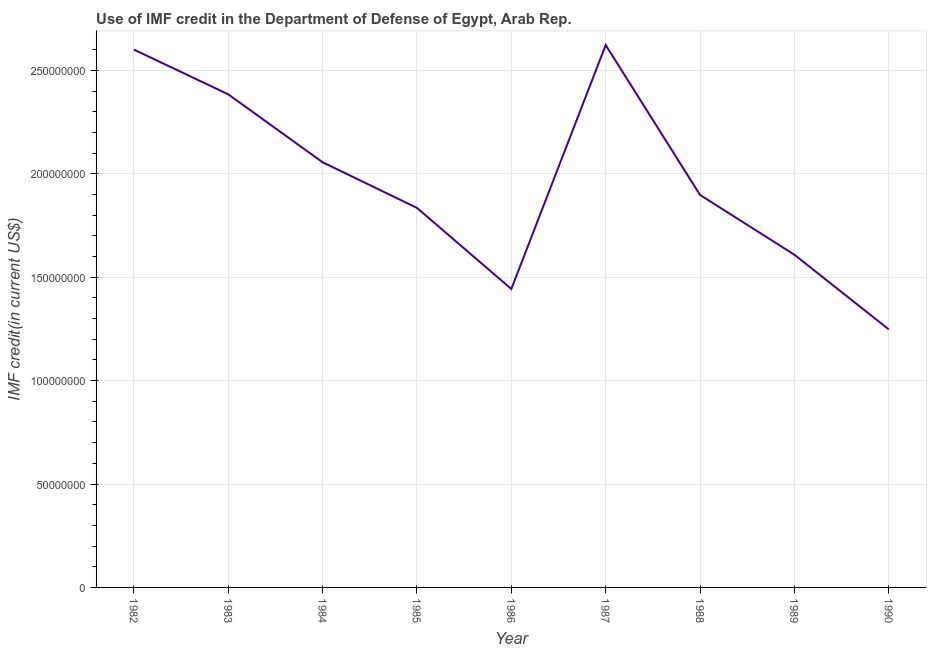What is the use of imf credit in dod in 1987?
Your answer should be very brief. 2.62e+08. Across all years, what is the maximum use of imf credit in dod?
Offer a terse response. 2.62e+08. Across all years, what is the minimum use of imf credit in dod?
Make the answer very short. 1.25e+08. In which year was the use of imf credit in dod minimum?
Your answer should be very brief. 1990. What is the sum of the use of imf credit in dod?
Offer a very short reply. 1.77e+09. What is the difference between the use of imf credit in dod in 1988 and 1990?
Make the answer very short. 6.50e+07. What is the average use of imf credit in dod per year?
Provide a succinct answer. 1.97e+08. What is the median use of imf credit in dod?
Provide a short and direct response. 1.90e+08. What is the ratio of the use of imf credit in dod in 1982 to that in 1983?
Provide a short and direct response. 1.09. Is the difference between the use of imf credit in dod in 1985 and 1986 greater than the difference between any two years?
Your answer should be very brief. No. What is the difference between the highest and the second highest use of imf credit in dod?
Offer a very short reply. 2.21e+06. Is the sum of the use of imf credit in dod in 1985 and 1988 greater than the maximum use of imf credit in dod across all years?
Ensure brevity in your answer.  Yes. What is the difference between the highest and the lowest use of imf credit in dod?
Provide a short and direct response. 1.37e+08. In how many years, is the use of imf credit in dod greater than the average use of imf credit in dod taken over all years?
Offer a very short reply. 4. Does the graph contain grids?
Offer a very short reply. Yes. What is the title of the graph?
Ensure brevity in your answer.  Use of IMF credit in the Department of Defense of Egypt, Arab Rep. What is the label or title of the X-axis?
Give a very brief answer. Year. What is the label or title of the Y-axis?
Provide a short and direct response. IMF credit(in current US$). What is the IMF credit(in current US$) in 1982?
Give a very brief answer. 2.60e+08. What is the IMF credit(in current US$) of 1983?
Give a very brief answer. 2.38e+08. What is the IMF credit(in current US$) of 1984?
Your answer should be very brief. 2.06e+08. What is the IMF credit(in current US$) of 1985?
Your answer should be very brief. 1.84e+08. What is the IMF credit(in current US$) of 1986?
Provide a short and direct response. 1.44e+08. What is the IMF credit(in current US$) of 1987?
Give a very brief answer. 2.62e+08. What is the IMF credit(in current US$) in 1988?
Make the answer very short. 1.90e+08. What is the IMF credit(in current US$) in 1989?
Your answer should be compact. 1.61e+08. What is the IMF credit(in current US$) in 1990?
Offer a very short reply. 1.25e+08. What is the difference between the IMF credit(in current US$) in 1982 and 1983?
Keep it short and to the point. 2.16e+07. What is the difference between the IMF credit(in current US$) in 1982 and 1984?
Your response must be concise. 5.45e+07. What is the difference between the IMF credit(in current US$) in 1982 and 1985?
Your answer should be compact. 7.65e+07. What is the difference between the IMF credit(in current US$) in 1982 and 1986?
Provide a short and direct response. 1.16e+08. What is the difference between the IMF credit(in current US$) in 1982 and 1987?
Your answer should be very brief. -2.21e+06. What is the difference between the IMF credit(in current US$) in 1982 and 1988?
Your answer should be compact. 7.03e+07. What is the difference between the IMF credit(in current US$) in 1982 and 1989?
Your response must be concise. 9.92e+07. What is the difference between the IMF credit(in current US$) in 1982 and 1990?
Ensure brevity in your answer.  1.35e+08. What is the difference between the IMF credit(in current US$) in 1983 and 1984?
Your response must be concise. 3.28e+07. What is the difference between the IMF credit(in current US$) in 1983 and 1985?
Your answer should be very brief. 5.49e+07. What is the difference between the IMF credit(in current US$) in 1983 and 1986?
Your answer should be compact. 9.41e+07. What is the difference between the IMF credit(in current US$) in 1983 and 1987?
Give a very brief answer. -2.38e+07. What is the difference between the IMF credit(in current US$) in 1983 and 1988?
Keep it short and to the point. 4.86e+07. What is the difference between the IMF credit(in current US$) in 1983 and 1989?
Your answer should be very brief. 7.76e+07. What is the difference between the IMF credit(in current US$) in 1983 and 1990?
Your answer should be compact. 1.14e+08. What is the difference between the IMF credit(in current US$) in 1984 and 1985?
Give a very brief answer. 2.21e+07. What is the difference between the IMF credit(in current US$) in 1984 and 1986?
Your response must be concise. 6.13e+07. What is the difference between the IMF credit(in current US$) in 1984 and 1987?
Ensure brevity in your answer.  -5.67e+07. What is the difference between the IMF credit(in current US$) in 1984 and 1988?
Provide a succinct answer. 1.58e+07. What is the difference between the IMF credit(in current US$) in 1984 and 1989?
Offer a terse response. 4.47e+07. What is the difference between the IMF credit(in current US$) in 1984 and 1990?
Your response must be concise. 8.08e+07. What is the difference between the IMF credit(in current US$) in 1985 and 1986?
Offer a very short reply. 3.92e+07. What is the difference between the IMF credit(in current US$) in 1985 and 1987?
Make the answer very short. -7.87e+07. What is the difference between the IMF credit(in current US$) in 1985 and 1988?
Your response must be concise. -6.26e+06. What is the difference between the IMF credit(in current US$) in 1985 and 1989?
Provide a short and direct response. 2.26e+07. What is the difference between the IMF credit(in current US$) in 1985 and 1990?
Your answer should be compact. 5.87e+07. What is the difference between the IMF credit(in current US$) in 1986 and 1987?
Keep it short and to the point. -1.18e+08. What is the difference between the IMF credit(in current US$) in 1986 and 1988?
Your answer should be very brief. -4.55e+07. What is the difference between the IMF credit(in current US$) in 1986 and 1989?
Your answer should be very brief. -1.66e+07. What is the difference between the IMF credit(in current US$) in 1986 and 1990?
Keep it short and to the point. 1.95e+07. What is the difference between the IMF credit(in current US$) in 1987 and 1988?
Keep it short and to the point. 7.25e+07. What is the difference between the IMF credit(in current US$) in 1987 and 1989?
Give a very brief answer. 1.01e+08. What is the difference between the IMF credit(in current US$) in 1987 and 1990?
Provide a succinct answer. 1.37e+08. What is the difference between the IMF credit(in current US$) in 1988 and 1989?
Your answer should be compact. 2.89e+07. What is the difference between the IMF credit(in current US$) in 1988 and 1990?
Keep it short and to the point. 6.50e+07. What is the difference between the IMF credit(in current US$) in 1989 and 1990?
Give a very brief answer. 3.61e+07. What is the ratio of the IMF credit(in current US$) in 1982 to that in 1983?
Offer a very short reply. 1.09. What is the ratio of the IMF credit(in current US$) in 1982 to that in 1984?
Your response must be concise. 1.26. What is the ratio of the IMF credit(in current US$) in 1982 to that in 1985?
Your answer should be compact. 1.42. What is the ratio of the IMF credit(in current US$) in 1982 to that in 1986?
Ensure brevity in your answer.  1.8. What is the ratio of the IMF credit(in current US$) in 1982 to that in 1988?
Your answer should be very brief. 1.37. What is the ratio of the IMF credit(in current US$) in 1982 to that in 1989?
Give a very brief answer. 1.62. What is the ratio of the IMF credit(in current US$) in 1982 to that in 1990?
Offer a terse response. 2.08. What is the ratio of the IMF credit(in current US$) in 1983 to that in 1984?
Your response must be concise. 1.16. What is the ratio of the IMF credit(in current US$) in 1983 to that in 1985?
Make the answer very short. 1.3. What is the ratio of the IMF credit(in current US$) in 1983 to that in 1986?
Provide a short and direct response. 1.65. What is the ratio of the IMF credit(in current US$) in 1983 to that in 1987?
Provide a short and direct response. 0.91. What is the ratio of the IMF credit(in current US$) in 1983 to that in 1988?
Give a very brief answer. 1.26. What is the ratio of the IMF credit(in current US$) in 1983 to that in 1989?
Ensure brevity in your answer.  1.48. What is the ratio of the IMF credit(in current US$) in 1983 to that in 1990?
Ensure brevity in your answer.  1.91. What is the ratio of the IMF credit(in current US$) in 1984 to that in 1985?
Your answer should be very brief. 1.12. What is the ratio of the IMF credit(in current US$) in 1984 to that in 1986?
Offer a very short reply. 1.43. What is the ratio of the IMF credit(in current US$) in 1984 to that in 1987?
Provide a succinct answer. 0.78. What is the ratio of the IMF credit(in current US$) in 1984 to that in 1988?
Provide a short and direct response. 1.08. What is the ratio of the IMF credit(in current US$) in 1984 to that in 1989?
Keep it short and to the point. 1.28. What is the ratio of the IMF credit(in current US$) in 1984 to that in 1990?
Your answer should be very brief. 1.65. What is the ratio of the IMF credit(in current US$) in 1985 to that in 1986?
Offer a terse response. 1.27. What is the ratio of the IMF credit(in current US$) in 1985 to that in 1988?
Offer a very short reply. 0.97. What is the ratio of the IMF credit(in current US$) in 1985 to that in 1989?
Ensure brevity in your answer.  1.14. What is the ratio of the IMF credit(in current US$) in 1985 to that in 1990?
Offer a terse response. 1.47. What is the ratio of the IMF credit(in current US$) in 1986 to that in 1987?
Offer a terse response. 0.55. What is the ratio of the IMF credit(in current US$) in 1986 to that in 1988?
Offer a terse response. 0.76. What is the ratio of the IMF credit(in current US$) in 1986 to that in 1989?
Your answer should be compact. 0.9. What is the ratio of the IMF credit(in current US$) in 1986 to that in 1990?
Give a very brief answer. 1.16. What is the ratio of the IMF credit(in current US$) in 1987 to that in 1988?
Offer a very short reply. 1.38. What is the ratio of the IMF credit(in current US$) in 1987 to that in 1989?
Provide a succinct answer. 1.63. What is the ratio of the IMF credit(in current US$) in 1987 to that in 1990?
Provide a short and direct response. 2.1. What is the ratio of the IMF credit(in current US$) in 1988 to that in 1989?
Provide a short and direct response. 1.18. What is the ratio of the IMF credit(in current US$) in 1988 to that in 1990?
Make the answer very short. 1.52. What is the ratio of the IMF credit(in current US$) in 1989 to that in 1990?
Your answer should be compact. 1.29. 